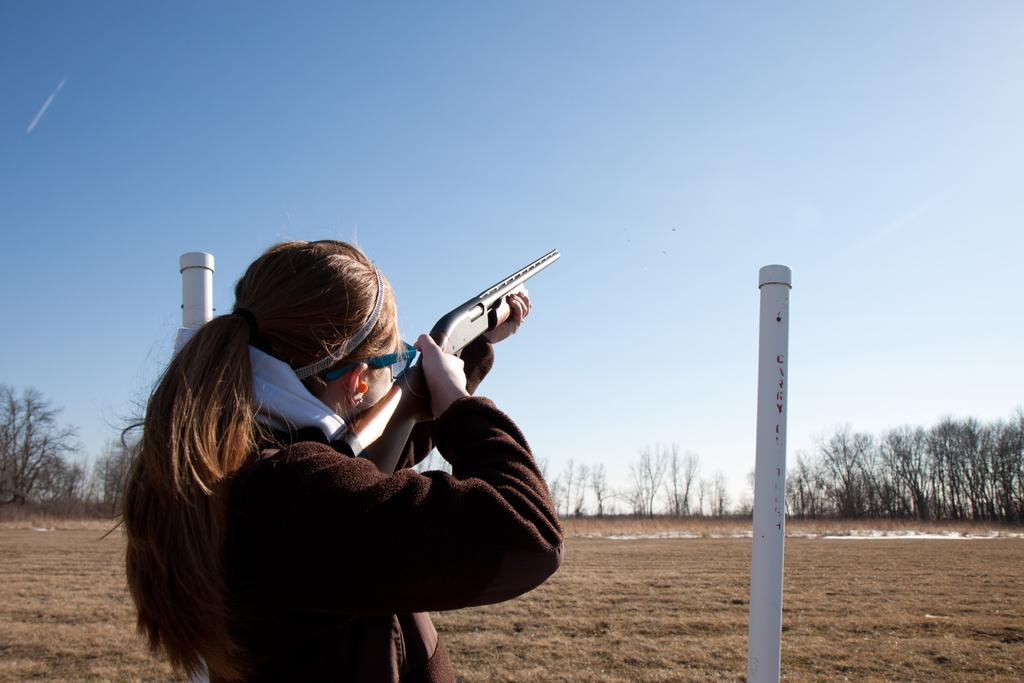Who is present in the image? There is a woman in the image. What is the woman holding in the image? The woman is holding a gun. What can be seen in the background of the image? There are poles, trees, and the sky visible in the background of the image. What is the color of the sky in the image? The sky is blue in color. What type of poison is the woman using to kill the cent in the image? There is no cent or poison present in the image. How many crows are visible in the image? There are no crows present in the image. 